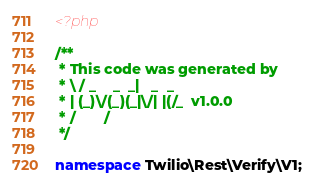<code> <loc_0><loc_0><loc_500><loc_500><_PHP_><?php

/**
 * This code was generated by
 * \ / _    _  _|   _  _
 * | (_)\/(_)(_|\/| |(/_  v1.0.0
 * /       /
 */

namespace Twilio\Rest\Verify\V1;
</code> 